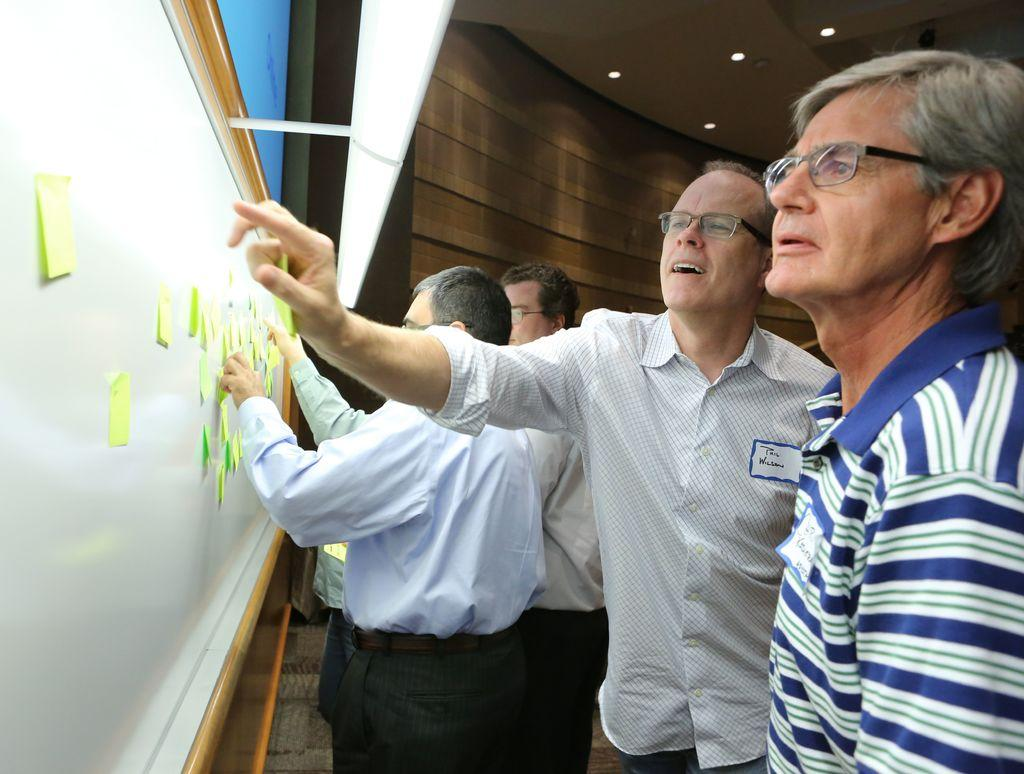What are the people in the image standing in front of? The people are standing in front of a whiteboard. What is attached to the whiteboard? There are papers attached to the whiteboard. What can be seen at the top of the image? There are lights visible at the top of the image. What is visible in the background of the image? There is a wall in the background of the image. Can you see any combs in the image? There is no comb present in the image. What type of shoes are the people wearing in the image? The image does not show the people's shoes, so it cannot be determined from the image. 